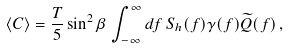<formula> <loc_0><loc_0><loc_500><loc_500>\langle C \rangle = \frac { T } { 5 } \sin ^ { 2 } \beta \, \int ^ { \infty } _ { - \infty } d f \, S _ { h } ( f ) \gamma ( f ) \widetilde { Q } ( f ) \, ,</formula> 